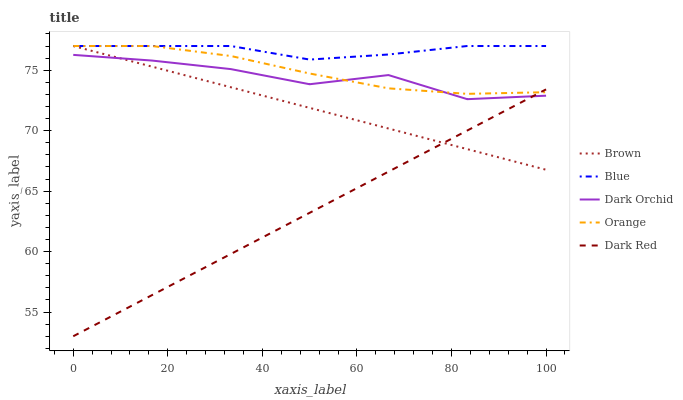Does Dark Red have the minimum area under the curve?
Answer yes or no. Yes. Does Blue have the maximum area under the curve?
Answer yes or no. Yes. Does Brown have the minimum area under the curve?
Answer yes or no. No. Does Brown have the maximum area under the curve?
Answer yes or no. No. Is Dark Red the smoothest?
Answer yes or no. Yes. Is Dark Orchid the roughest?
Answer yes or no. Yes. Is Brown the smoothest?
Answer yes or no. No. Is Brown the roughest?
Answer yes or no. No. Does Dark Red have the lowest value?
Answer yes or no. Yes. Does Brown have the lowest value?
Answer yes or no. No. Does Orange have the highest value?
Answer yes or no. Yes. Does Dark Orchid have the highest value?
Answer yes or no. No. Is Dark Orchid less than Blue?
Answer yes or no. Yes. Is Blue greater than Dark Orchid?
Answer yes or no. Yes. Does Dark Orchid intersect Brown?
Answer yes or no. Yes. Is Dark Orchid less than Brown?
Answer yes or no. No. Is Dark Orchid greater than Brown?
Answer yes or no. No. Does Dark Orchid intersect Blue?
Answer yes or no. No. 